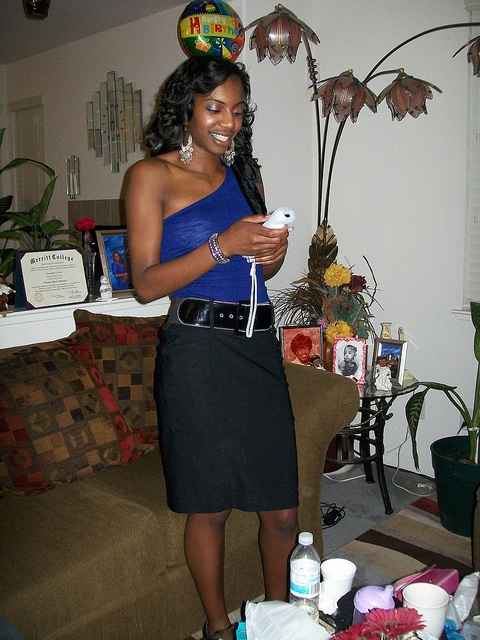Describe the objects in this image and their specific colors. I can see people in black, maroon, brown, and navy tones, couch in black and gray tones, couch in black, maroon, and lightgray tones, potted plant in black, gray, darkgray, and maroon tones, and potted plant in black, darkgray, darkgreen, and gray tones in this image. 